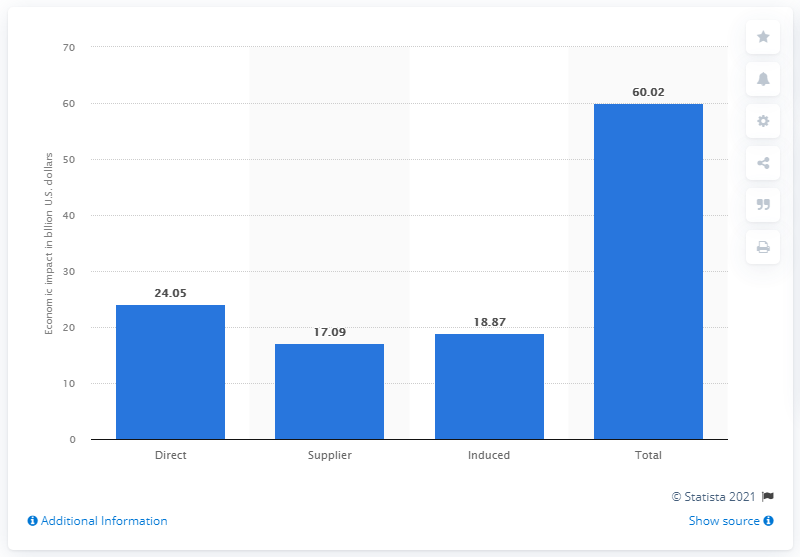Highlight a few significant elements in this photo. The induced economic impact of the U.S. sporting arms and ammunition industry in 2019 was 18.87. In 2019, the U.S. sporting arms and ammunition industry had an induced economic impact of 18.87 billion dollars. 